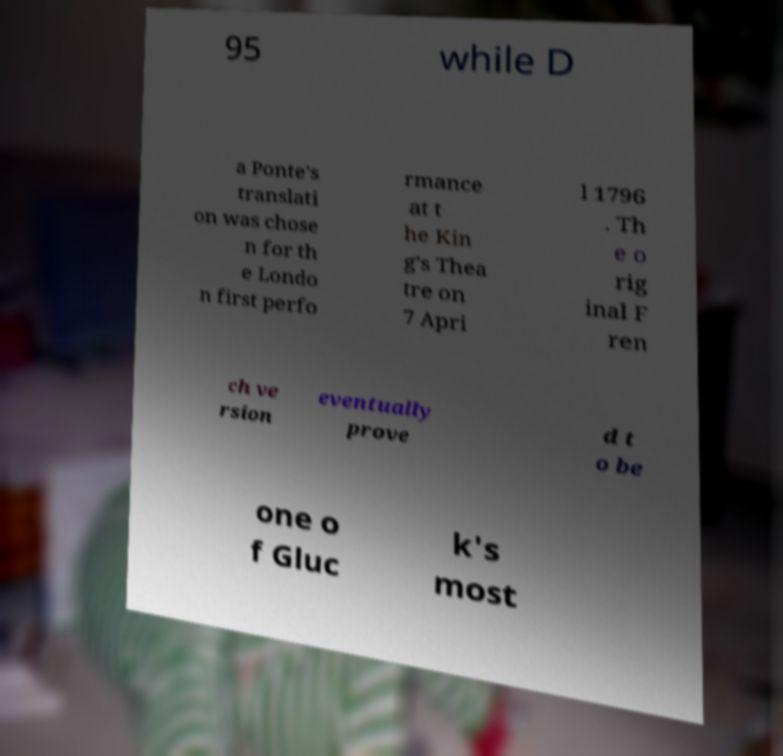There's text embedded in this image that I need extracted. Can you transcribe it verbatim? 95 while D a Ponte's translati on was chose n for th e Londo n first perfo rmance at t he Kin g's Thea tre on 7 Apri l 1796 . Th e o rig inal F ren ch ve rsion eventually prove d t o be one o f Gluc k's most 